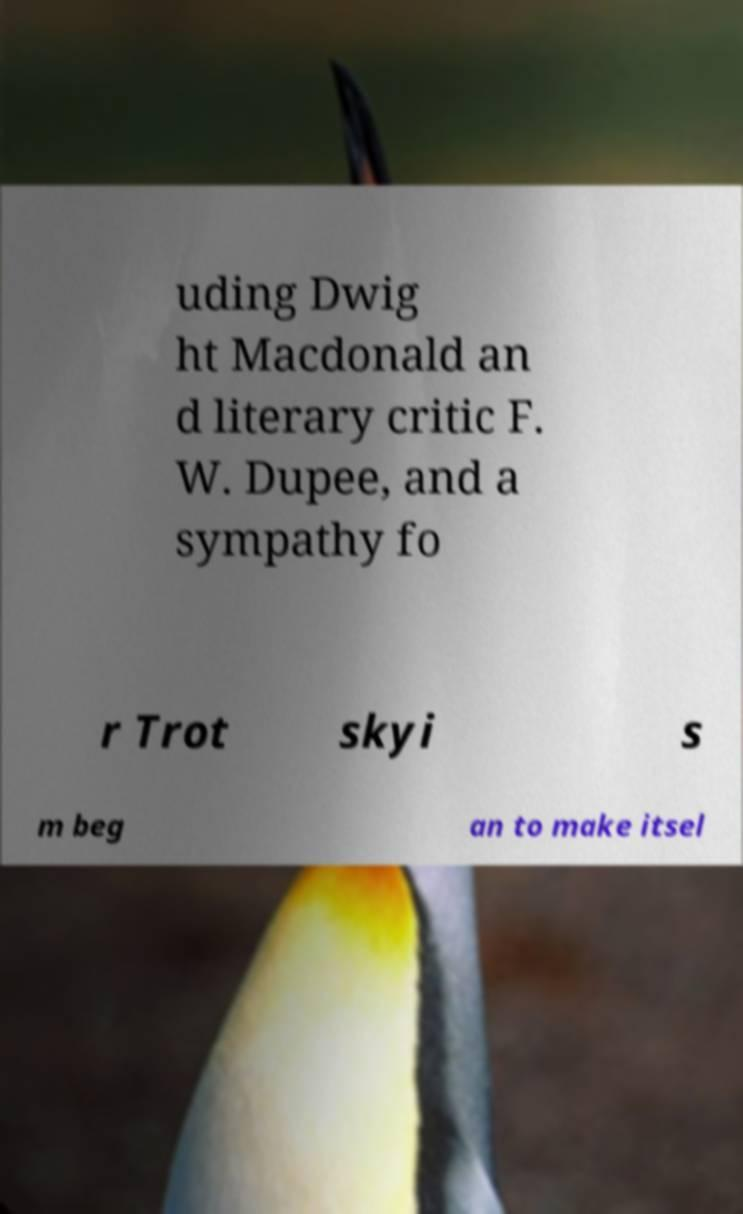Could you assist in decoding the text presented in this image and type it out clearly? uding Dwig ht Macdonald an d literary critic F. W. Dupee, and a sympathy fo r Trot skyi s m beg an to make itsel 